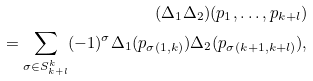<formula> <loc_0><loc_0><loc_500><loc_500>( \Delta _ { 1 } \Delta _ { 2 } ) ( p _ { 1 } , \dots , p _ { k + l } ) \\ = \sum _ { \sigma \in S _ { k + l } ^ { k } } ( - 1 ) ^ { \sigma } \Delta _ { 1 } ( p _ { \sigma ( 1 , k ) } ) \Delta _ { 2 } ( p _ { \sigma ( k + 1 , k + l ) } ) ,</formula> 